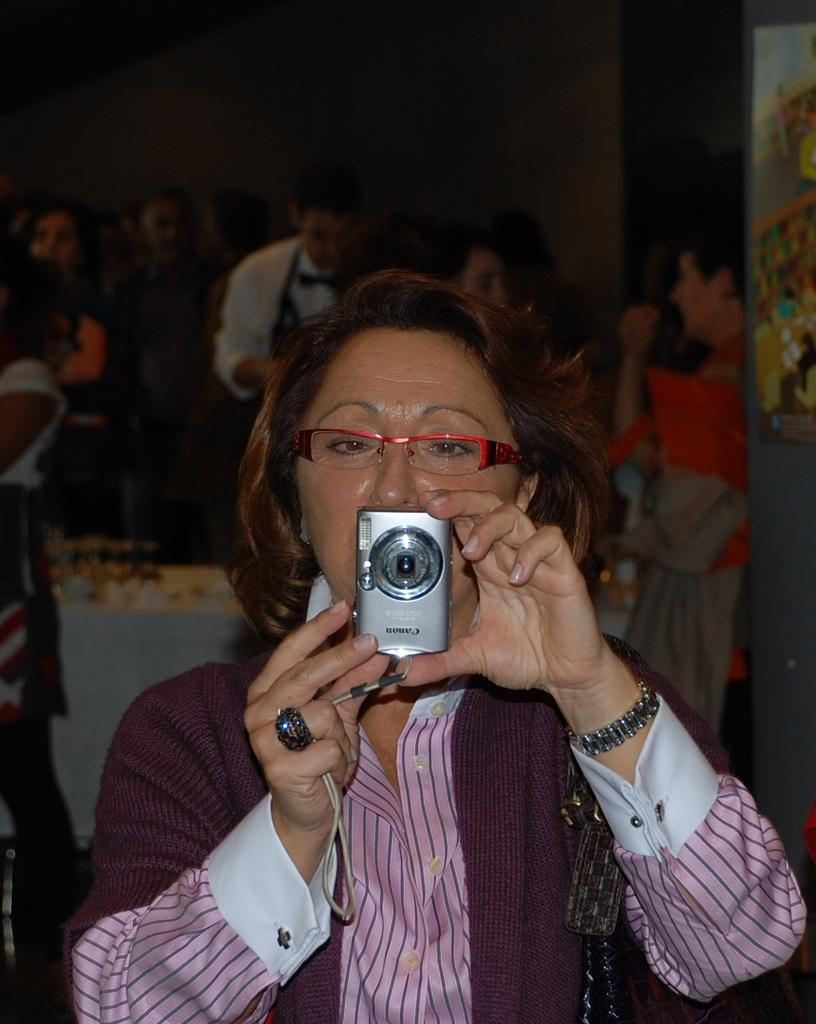Who is the main subject in the image? There is a woman in the image. What is the woman holding in the image? The woman is holding a camera. What color is the shirt the woman is wearing? The woman is wearing a pink colored shirt. Can you describe the background of the image? There are many people behind her in the image. What type of science experiment is being conducted by the frogs in the image? There are no frogs or science experiments present in the image. 